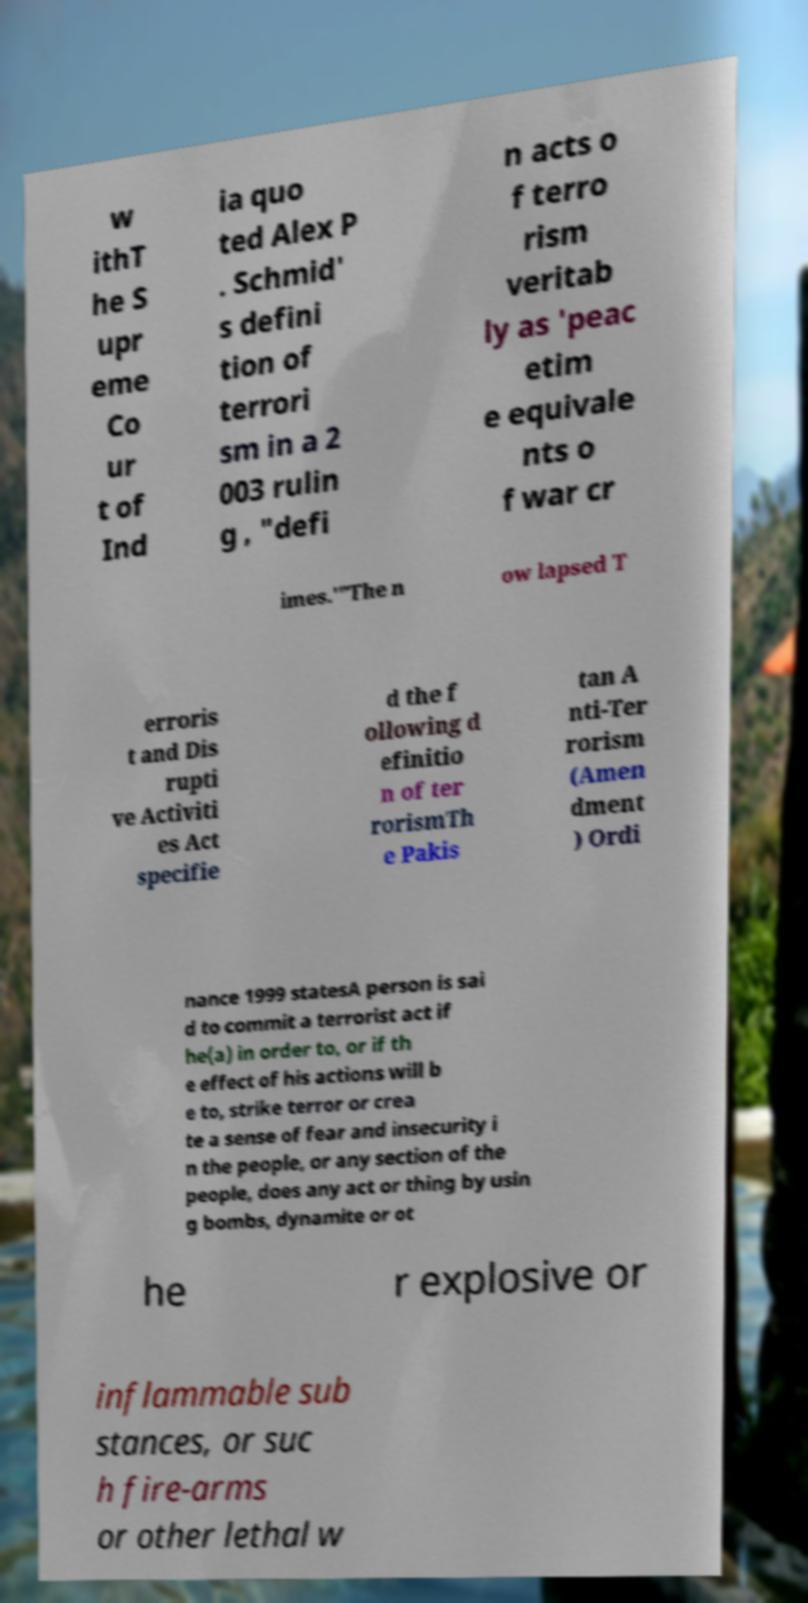Could you assist in decoding the text presented in this image and type it out clearly? w ithT he S upr eme Co ur t of Ind ia quo ted Alex P . Schmid' s defini tion of terrori sm in a 2 003 rulin g , "defi n acts o f terro rism veritab ly as 'peac etim e equivale nts o f war cr imes.'"The n ow lapsed T erroris t and Dis rupti ve Activiti es Act specifie d the f ollowing d efinitio n of ter rorismTh e Pakis tan A nti-Ter rorism (Amen dment ) Ordi nance 1999 statesA person is sai d to commit a terrorist act if he(a) in order to, or if th e effect of his actions will b e to, strike terror or crea te a sense of fear and insecurity i n the people, or any section of the people, does any act or thing by usin g bombs, dynamite or ot he r explosive or inflammable sub stances, or suc h fire-arms or other lethal w 